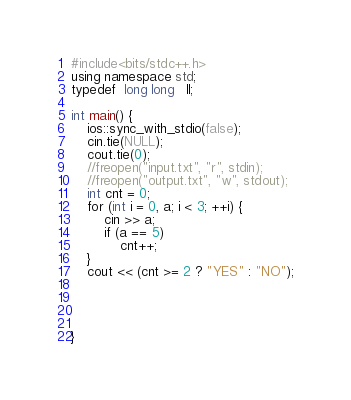<code> <loc_0><loc_0><loc_500><loc_500><_C++_>#include<bits/stdc++.h>
using namespace std;
typedef  long long   ll;

int main() {
	ios::sync_with_stdio(false);
	cin.tie(NULL);
	cout.tie(0);
	//freopen("input.txt", "r", stdin);
	//freopen("output.txt", "w", stdout);
	int cnt = 0;
	for (int i = 0, a; i < 3; ++i) {
		cin >> a;
		if (a == 5)
			cnt++;
	}
	cout << (cnt >= 2 ? "YES" : "NO");




}</code> 